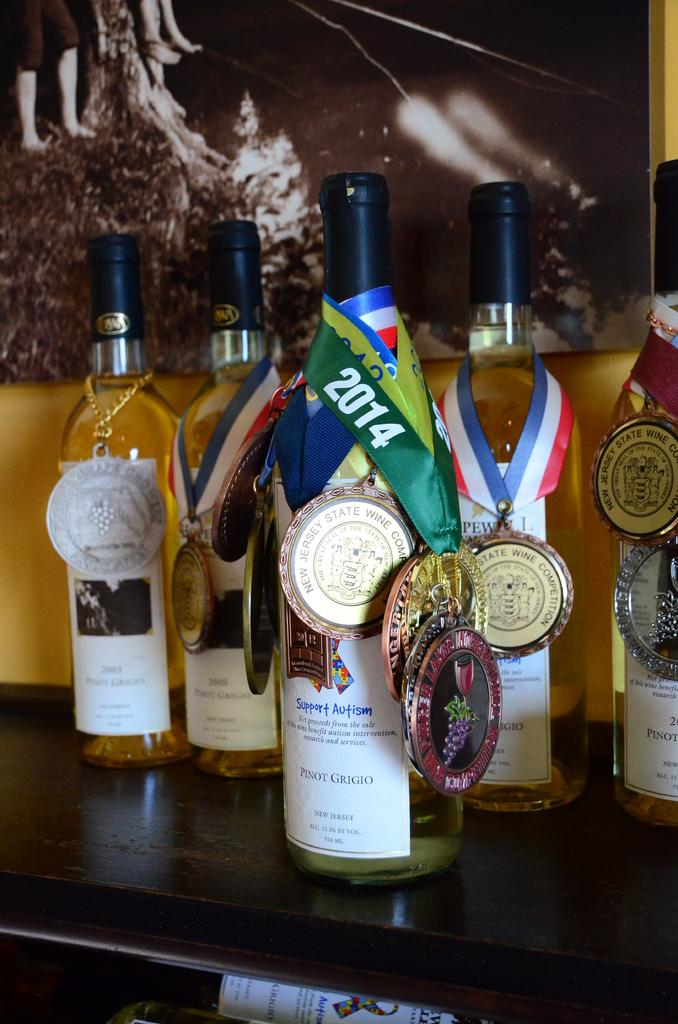<image>
Summarize the visual content of the image. A bottle of wine with an award that says 2014 is on a table. 